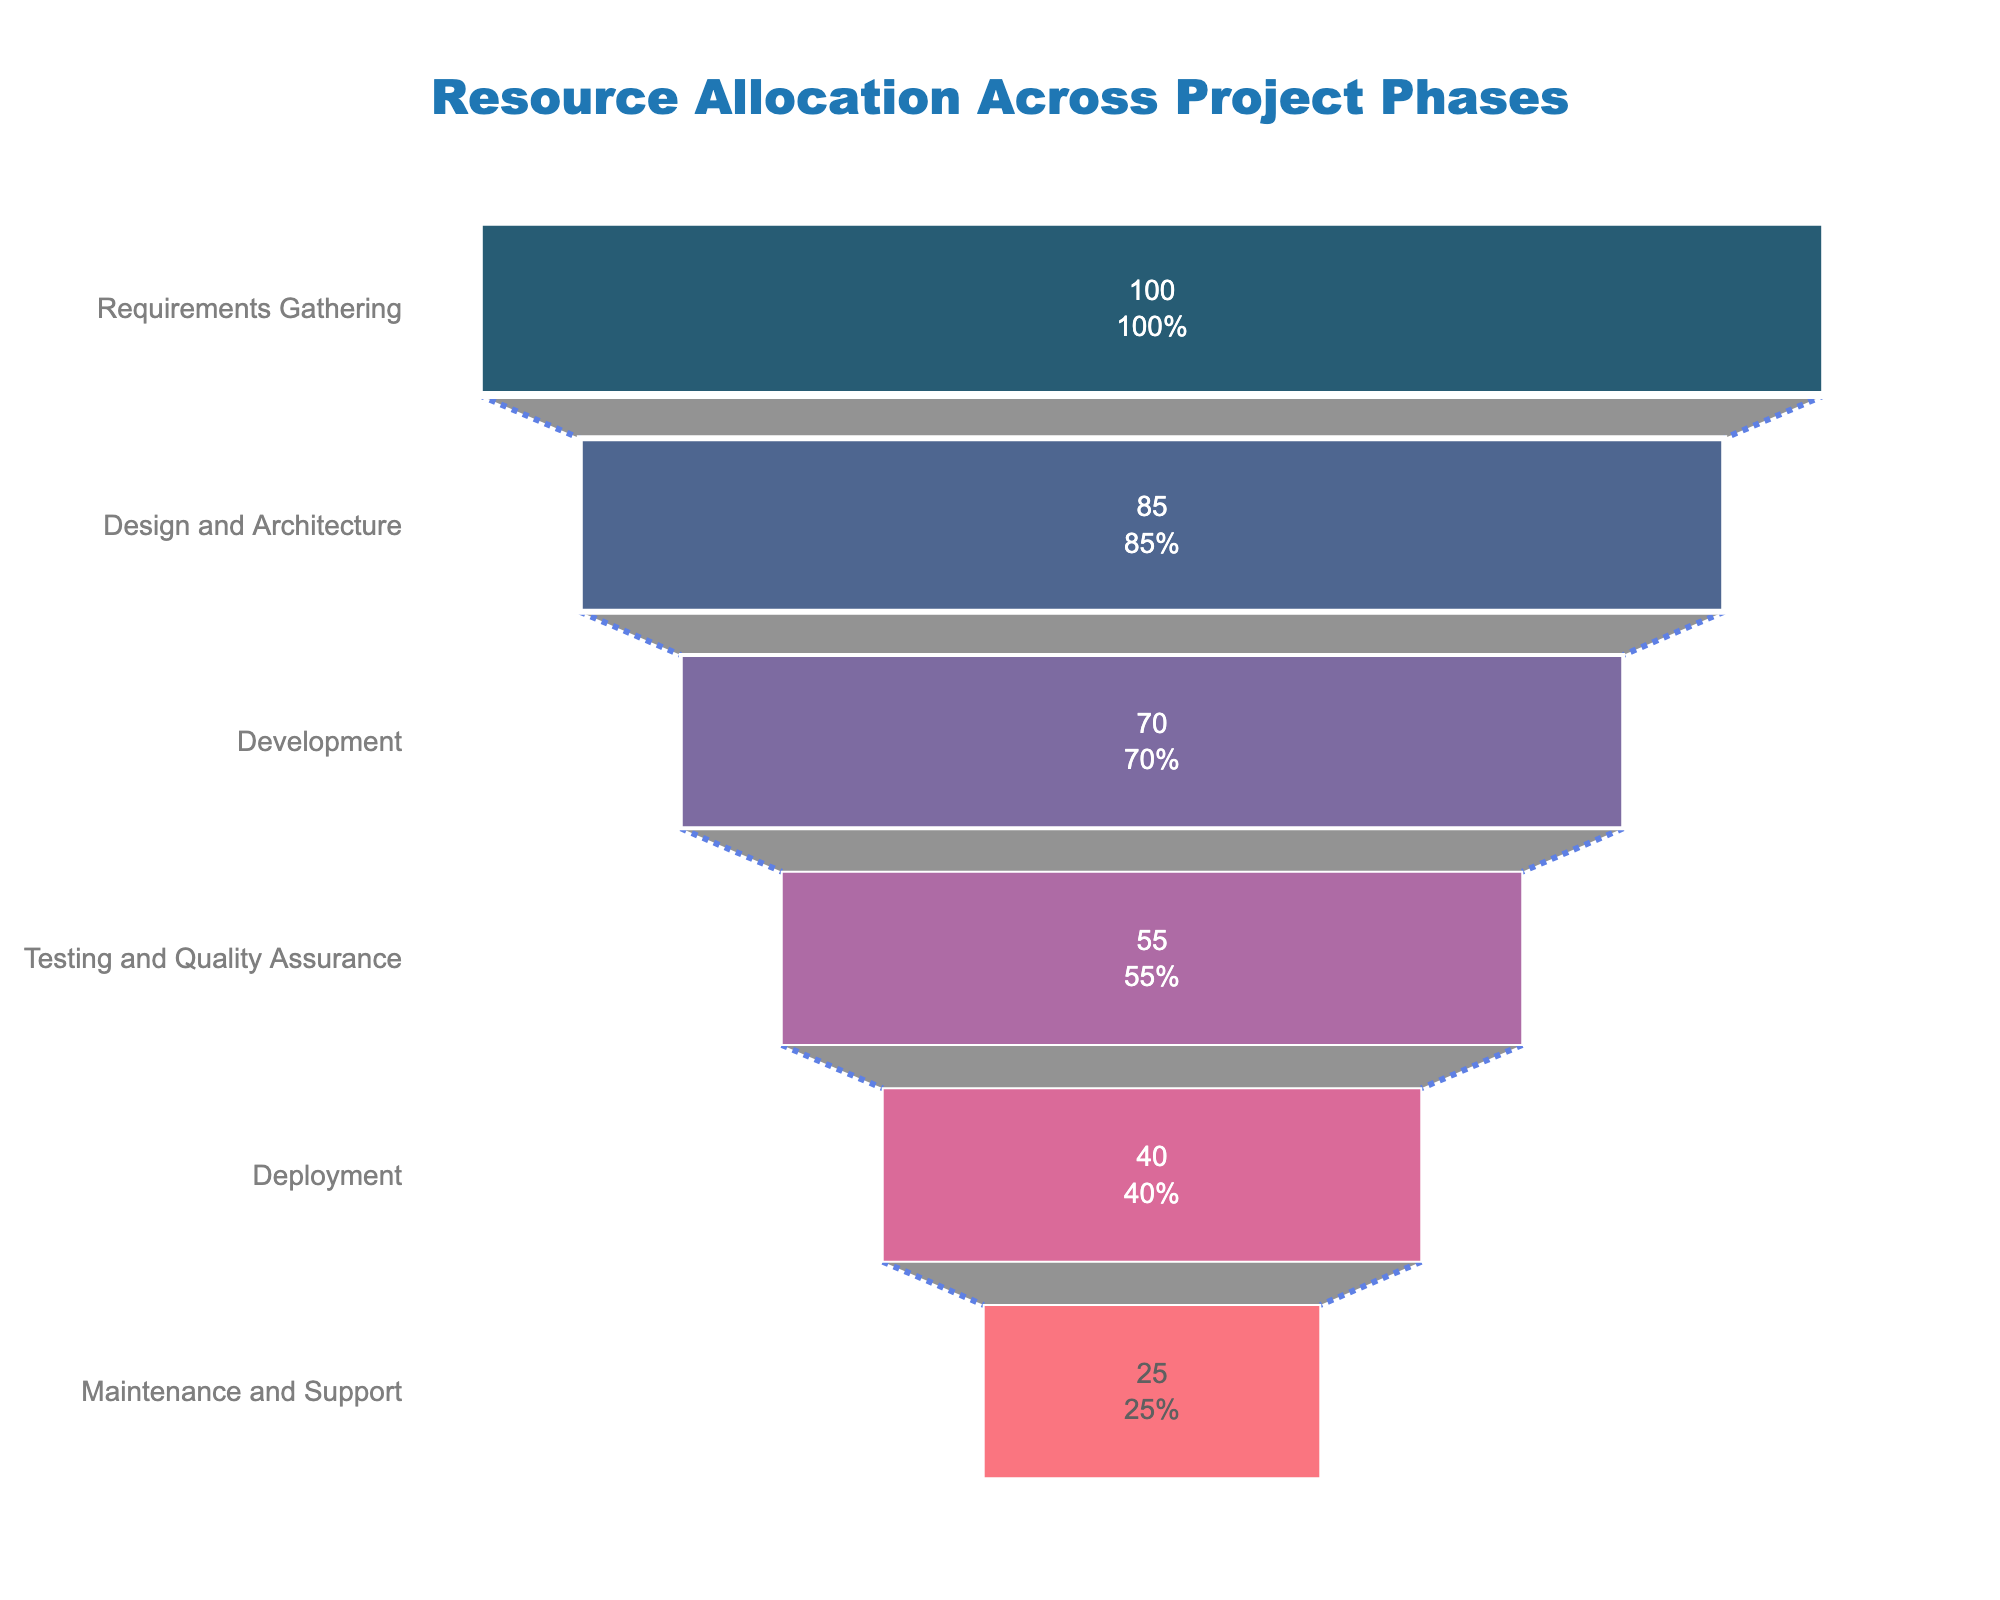What is the title of the figure? The title of the figure is situated at the top and centrally located within the plot layout. It is written in a bolded and colored font for emphasis.
Answer: Resource Allocation Across Project Phases Which project phase has the highest resource allocation? The phase with the highest resource allocation is the first one listed from the top of the funnel chart. By checking the values at the top, we see the phase and associated resource value.
Answer: Requirements Gathering How many project phases are depicted in the funnel chart? Count the number of distinct entries on the y-axis, which represent the different phases. Each phase is a separate block in the funnel chart.
Answer: 6 What percentage of the resources are allocated to the Development phase relative to the initial Resources Gathering phase? First identify the resources allocated to each phase: Development has 70, and Requirements Gathering has 100. Calculate the percentage using the formula: (70/100) * 100%.
Answer: 70% Which phase shows a greater decrease in resource allocation: Design and Architecture to Development or Testing and Quality Assurance to Deployment? Calculate the difference in resources between Design and Architecture (85) and Development (70), which is 15. Then, calculate the difference between Testing and Quality Assurance (55) and Deployment (40), which is also 15. Thus, both show equal decreases.
Answer: Both phases show an equal decrease What is the total amount of resources allocated from Design and Architecture to Maintenance and Support? Sum the allocated resources for Design and Architecture (85), Development (70), Testing and Quality Assurance (55), Deployment (40), and Maintenance and Support (25). The sum is 85 + 70 + 55 + 40 + 25.
Answer: 275 What color represents the Testing and Quality Assurance phase, and how is it visually distinguished? Check the color used for the Testing and Quality Assurance duration by matching it with the provided color legend. Also, note any distinct styles or boundaries.
Answer: Pinkish (#d45087) How much less resources are allocated to Maintenance and Support compared to Development? Retrieve resource values for both Maintenance and Support (25) and Development (70). Subtract the Maintenance and Support value from the Development value (70 - 25).
Answer: 45 Which phase follows immediately after Testing and Quality Assurance in the funnel chart? Identify the sequential order of phases by looking at the funnel chart positions. The next phase after Testing and Quality Assurance should be directly below it.
Answer: Deployment What is the average resource allocation across all project phases? Compute the total resources allocated by adding values from each phase: 100 + 85 + 70 + 55 + 40 + 25 = 375. Then, divide this sum by the number of phases, 6, to find the average.
Answer: 62.5 